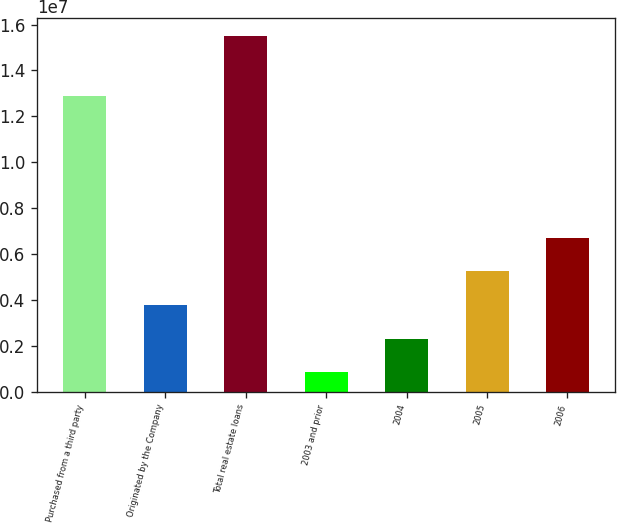<chart> <loc_0><loc_0><loc_500><loc_500><bar_chart><fcel>Purchased from a third party<fcel>Originated by the Company<fcel>Total real estate loans<fcel>2003 and prior<fcel>2004<fcel>2005<fcel>2006<nl><fcel>1.29048e+07<fcel>3.77704e+06<fcel>1.55065e+07<fcel>844670<fcel>2.31086e+06<fcel>5.24323e+06<fcel>6.70941e+06<nl></chart> 